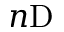Convert formula to latex. <formula><loc_0><loc_0><loc_500><loc_500>n D</formula> 